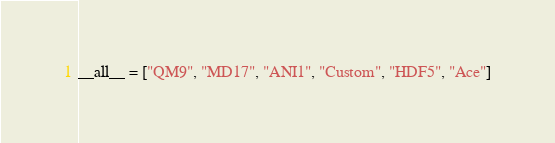Convert code to text. <code><loc_0><loc_0><loc_500><loc_500><_Python_>__all__ = ["QM9", "MD17", "ANI1", "Custom", "HDF5", "Ace"]
</code> 